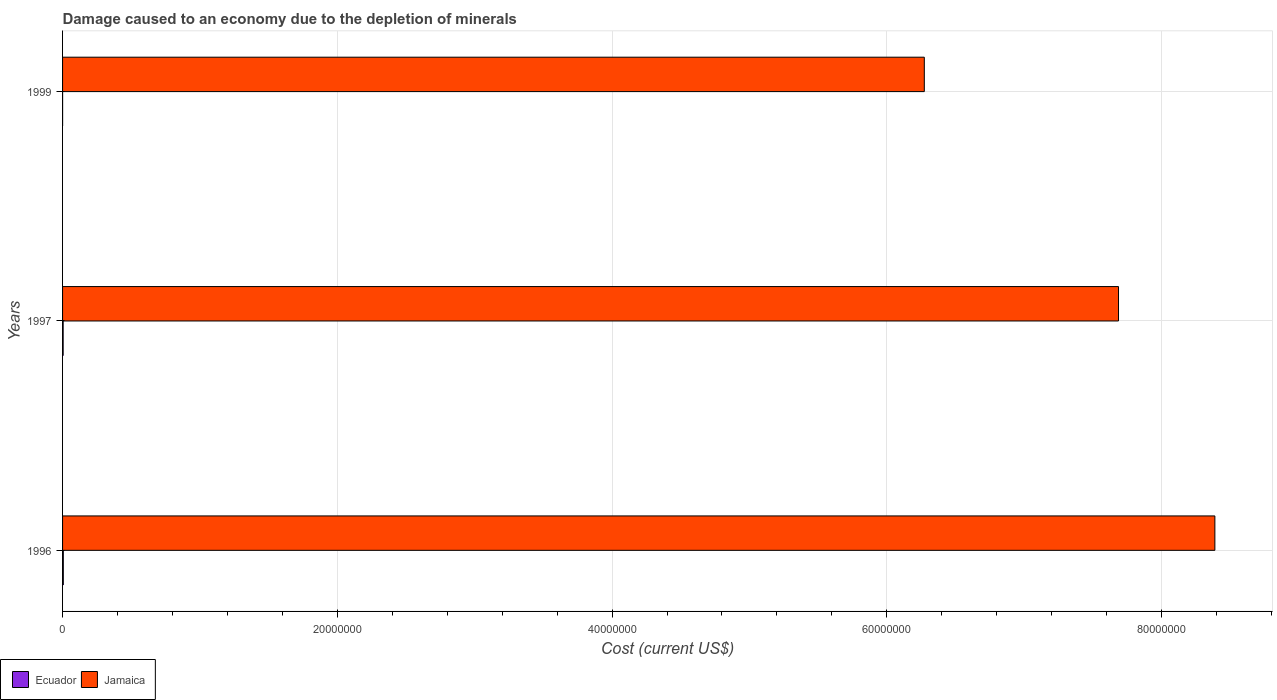How many different coloured bars are there?
Provide a short and direct response. 2. How many groups of bars are there?
Provide a succinct answer. 3. How many bars are there on the 1st tick from the top?
Offer a very short reply. 2. What is the label of the 3rd group of bars from the top?
Keep it short and to the point. 1996. In how many cases, is the number of bars for a given year not equal to the number of legend labels?
Provide a succinct answer. 0. What is the cost of damage caused due to the depletion of minerals in Jamaica in 1997?
Give a very brief answer. 7.69e+07. Across all years, what is the maximum cost of damage caused due to the depletion of minerals in Jamaica?
Ensure brevity in your answer.  8.39e+07. Across all years, what is the minimum cost of damage caused due to the depletion of minerals in Ecuador?
Give a very brief answer. 1827.62. What is the total cost of damage caused due to the depletion of minerals in Jamaica in the graph?
Make the answer very short. 2.23e+08. What is the difference between the cost of damage caused due to the depletion of minerals in Jamaica in 1997 and that in 1999?
Your response must be concise. 1.41e+07. What is the difference between the cost of damage caused due to the depletion of minerals in Ecuador in 1996 and the cost of damage caused due to the depletion of minerals in Jamaica in 1997?
Your answer should be compact. -7.68e+07. What is the average cost of damage caused due to the depletion of minerals in Jamaica per year?
Your response must be concise. 7.45e+07. In the year 1996, what is the difference between the cost of damage caused due to the depletion of minerals in Jamaica and cost of damage caused due to the depletion of minerals in Ecuador?
Your answer should be very brief. 8.38e+07. What is the ratio of the cost of damage caused due to the depletion of minerals in Jamaica in 1997 to that in 1999?
Ensure brevity in your answer.  1.23. Is the cost of damage caused due to the depletion of minerals in Ecuador in 1996 less than that in 1999?
Offer a terse response. No. Is the difference between the cost of damage caused due to the depletion of minerals in Jamaica in 1996 and 1999 greater than the difference between the cost of damage caused due to the depletion of minerals in Ecuador in 1996 and 1999?
Keep it short and to the point. Yes. What is the difference between the highest and the second highest cost of damage caused due to the depletion of minerals in Jamaica?
Offer a very short reply. 7.01e+06. What is the difference between the highest and the lowest cost of damage caused due to the depletion of minerals in Jamaica?
Your answer should be compact. 2.12e+07. Is the sum of the cost of damage caused due to the depletion of minerals in Jamaica in 1996 and 1997 greater than the maximum cost of damage caused due to the depletion of minerals in Ecuador across all years?
Offer a very short reply. Yes. What does the 2nd bar from the top in 1997 represents?
Give a very brief answer. Ecuador. What does the 2nd bar from the bottom in 1999 represents?
Provide a succinct answer. Jamaica. How many bars are there?
Provide a succinct answer. 6. How many years are there in the graph?
Keep it short and to the point. 3. Are the values on the major ticks of X-axis written in scientific E-notation?
Your answer should be compact. No. Does the graph contain any zero values?
Provide a short and direct response. No. Does the graph contain grids?
Give a very brief answer. Yes. Where does the legend appear in the graph?
Give a very brief answer. Bottom left. How many legend labels are there?
Make the answer very short. 2. What is the title of the graph?
Your response must be concise. Damage caused to an economy due to the depletion of minerals. Does "Lithuania" appear as one of the legend labels in the graph?
Offer a terse response. No. What is the label or title of the X-axis?
Your answer should be compact. Cost (current US$). What is the label or title of the Y-axis?
Your response must be concise. Years. What is the Cost (current US$) in Ecuador in 1996?
Provide a short and direct response. 5.43e+04. What is the Cost (current US$) of Jamaica in 1996?
Your answer should be compact. 8.39e+07. What is the Cost (current US$) in Ecuador in 1997?
Provide a succinct answer. 4.30e+04. What is the Cost (current US$) of Jamaica in 1997?
Keep it short and to the point. 7.69e+07. What is the Cost (current US$) of Ecuador in 1999?
Ensure brevity in your answer.  1827.62. What is the Cost (current US$) in Jamaica in 1999?
Your response must be concise. 6.27e+07. Across all years, what is the maximum Cost (current US$) of Ecuador?
Ensure brevity in your answer.  5.43e+04. Across all years, what is the maximum Cost (current US$) in Jamaica?
Your answer should be very brief. 8.39e+07. Across all years, what is the minimum Cost (current US$) of Ecuador?
Your answer should be compact. 1827.62. Across all years, what is the minimum Cost (current US$) in Jamaica?
Your response must be concise. 6.27e+07. What is the total Cost (current US$) of Ecuador in the graph?
Keep it short and to the point. 9.92e+04. What is the total Cost (current US$) in Jamaica in the graph?
Keep it short and to the point. 2.23e+08. What is the difference between the Cost (current US$) in Ecuador in 1996 and that in 1997?
Your response must be concise. 1.13e+04. What is the difference between the Cost (current US$) in Jamaica in 1996 and that in 1997?
Your answer should be compact. 7.01e+06. What is the difference between the Cost (current US$) in Ecuador in 1996 and that in 1999?
Your response must be concise. 5.25e+04. What is the difference between the Cost (current US$) in Jamaica in 1996 and that in 1999?
Provide a short and direct response. 2.12e+07. What is the difference between the Cost (current US$) of Ecuador in 1997 and that in 1999?
Make the answer very short. 4.12e+04. What is the difference between the Cost (current US$) of Jamaica in 1997 and that in 1999?
Provide a short and direct response. 1.41e+07. What is the difference between the Cost (current US$) of Ecuador in 1996 and the Cost (current US$) of Jamaica in 1997?
Make the answer very short. -7.68e+07. What is the difference between the Cost (current US$) of Ecuador in 1996 and the Cost (current US$) of Jamaica in 1999?
Offer a terse response. -6.27e+07. What is the difference between the Cost (current US$) of Ecuador in 1997 and the Cost (current US$) of Jamaica in 1999?
Give a very brief answer. -6.27e+07. What is the average Cost (current US$) of Ecuador per year?
Ensure brevity in your answer.  3.31e+04. What is the average Cost (current US$) in Jamaica per year?
Your answer should be compact. 7.45e+07. In the year 1996, what is the difference between the Cost (current US$) in Ecuador and Cost (current US$) in Jamaica?
Provide a short and direct response. -8.38e+07. In the year 1997, what is the difference between the Cost (current US$) in Ecuador and Cost (current US$) in Jamaica?
Your answer should be compact. -7.68e+07. In the year 1999, what is the difference between the Cost (current US$) in Ecuador and Cost (current US$) in Jamaica?
Make the answer very short. -6.27e+07. What is the ratio of the Cost (current US$) of Ecuador in 1996 to that in 1997?
Keep it short and to the point. 1.26. What is the ratio of the Cost (current US$) in Jamaica in 1996 to that in 1997?
Your answer should be very brief. 1.09. What is the ratio of the Cost (current US$) of Ecuador in 1996 to that in 1999?
Give a very brief answer. 29.73. What is the ratio of the Cost (current US$) in Jamaica in 1996 to that in 1999?
Offer a terse response. 1.34. What is the ratio of the Cost (current US$) of Ecuador in 1997 to that in 1999?
Your answer should be very brief. 23.55. What is the ratio of the Cost (current US$) of Jamaica in 1997 to that in 1999?
Offer a terse response. 1.23. What is the difference between the highest and the second highest Cost (current US$) in Ecuador?
Provide a succinct answer. 1.13e+04. What is the difference between the highest and the second highest Cost (current US$) in Jamaica?
Your response must be concise. 7.01e+06. What is the difference between the highest and the lowest Cost (current US$) of Ecuador?
Your answer should be very brief. 5.25e+04. What is the difference between the highest and the lowest Cost (current US$) of Jamaica?
Provide a short and direct response. 2.12e+07. 